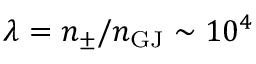Convert formula to latex. <formula><loc_0><loc_0><loc_500><loc_500>\lambda = n _ { \pm } / n _ { G J } \sim 1 0 ^ { 4 }</formula> 